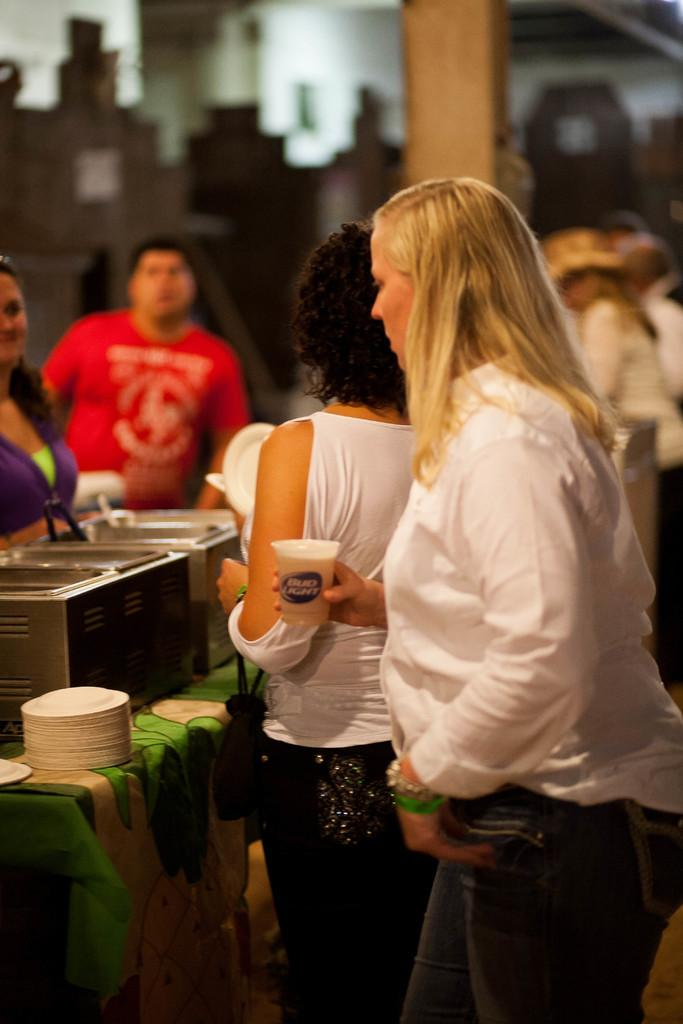What can be seen in the image involving people? There are people standing in the image. What is on the table in the image? There are objects on a table in the image. Can you describe the background of the image? The background of the image is blurry. What type of book is being read by the person in the image? There is no book or person reading a book present in the image. 